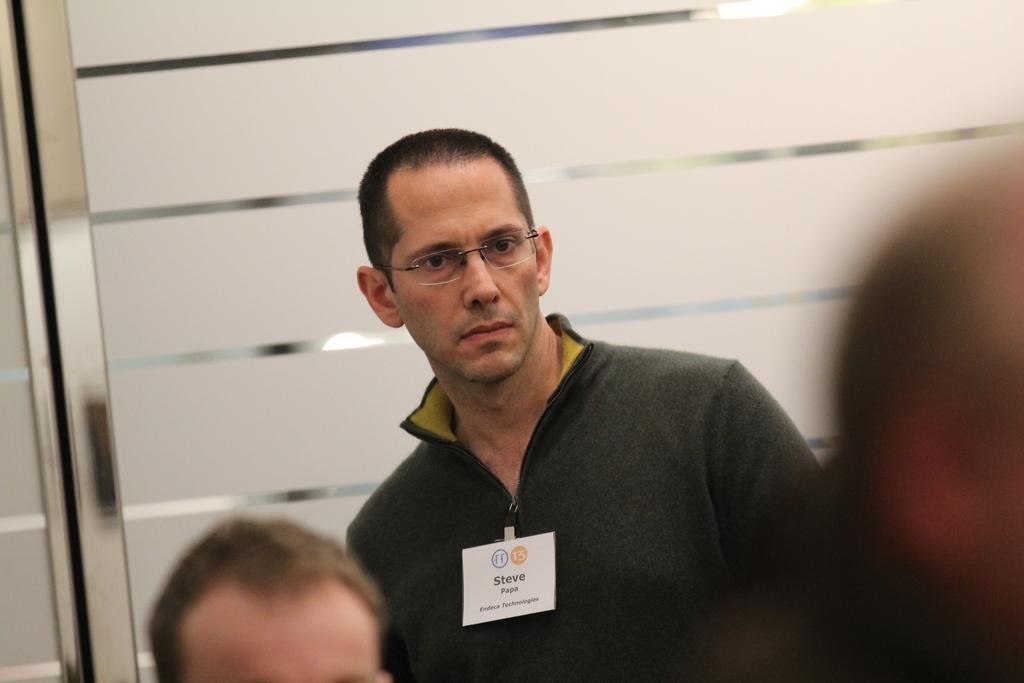Please provide a concise description of this image. In this picture we can see a person wearing a spectacle and standing. We can see the head of a person. There are glass objects. Through these glass objects, we can see the lights. 